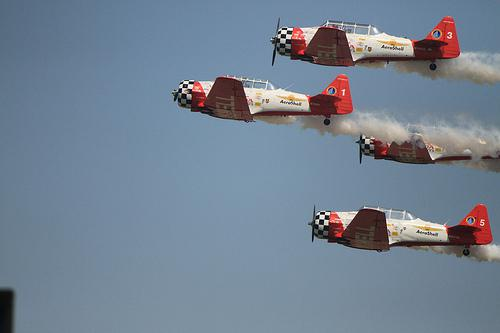Question: what is in the photo?
Choices:
A. Cars.
B. Flowers.
C. Planes.
D. People.
Answer with the letter. Answer: C Question: why are they flying in formation?
Choices:
A. It is a show.
B. It is a air show.
C. It is a flight test.
D. It is to support one another.
Answer with the letter. Answer: A Question: what color are the planes?
Choices:
A. White, red and black.
B. Gold, silver and green.
C. Blue, orange and tan.
D. Green, silver and gold.
Answer with the letter. Answer: A Question: where was the photo taken?
Choices:
A. Outdoors at a park.
B. Outdoors at a beach.
C. Outdoors at an air show.
D. Outdoors at a neighborhood block party.
Answer with the letter. Answer: C Question: who is in the picture?
Choices:
A. Four pilots in their planes.
B. Three firefighters in their uniform.
C. Two police officers in their squad car.
D. One teacher in his classroom.
Answer with the letter. Answer: A 